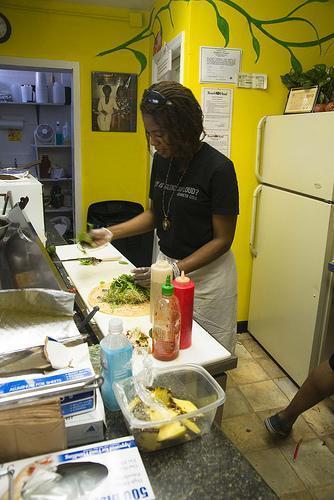How many people are there?
Give a very brief answer. 1. How many necklaces is the woman in the black shirt wearing?
Give a very brief answer. 1. 